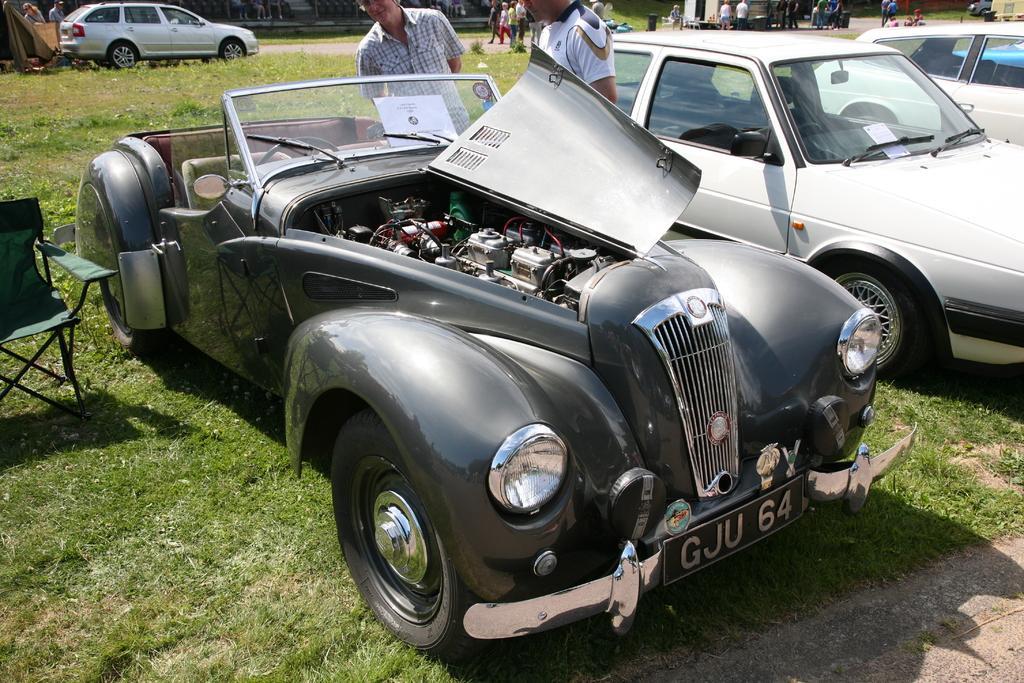Describe this image in one or two sentences. In this picture I can see there is a car, the engine of the car is visible and there are two persons standing here and there is a chair into left and there is grass on the floor. There are few other cars on to right and in the backdrop, there are few people walking and there is another car here. 